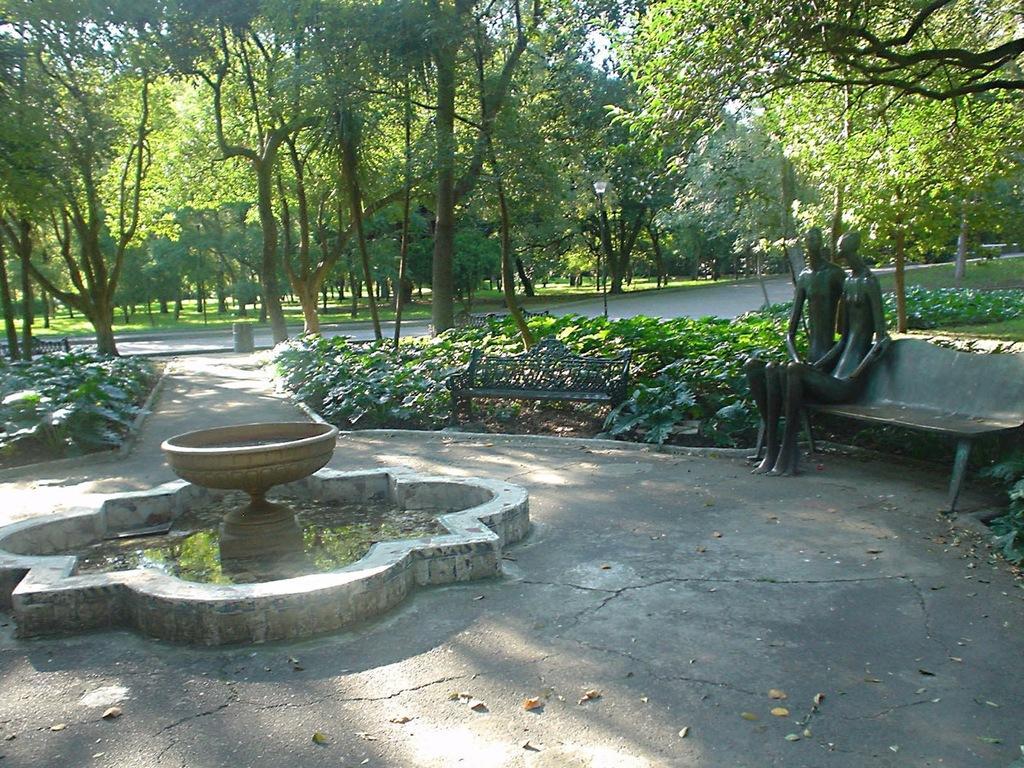In one or two sentences, can you explain what this image depicts? In this picture, it seems like a fountain and sculptures in the foreground area of the image, there are trees, grassland and the sky in the background. 